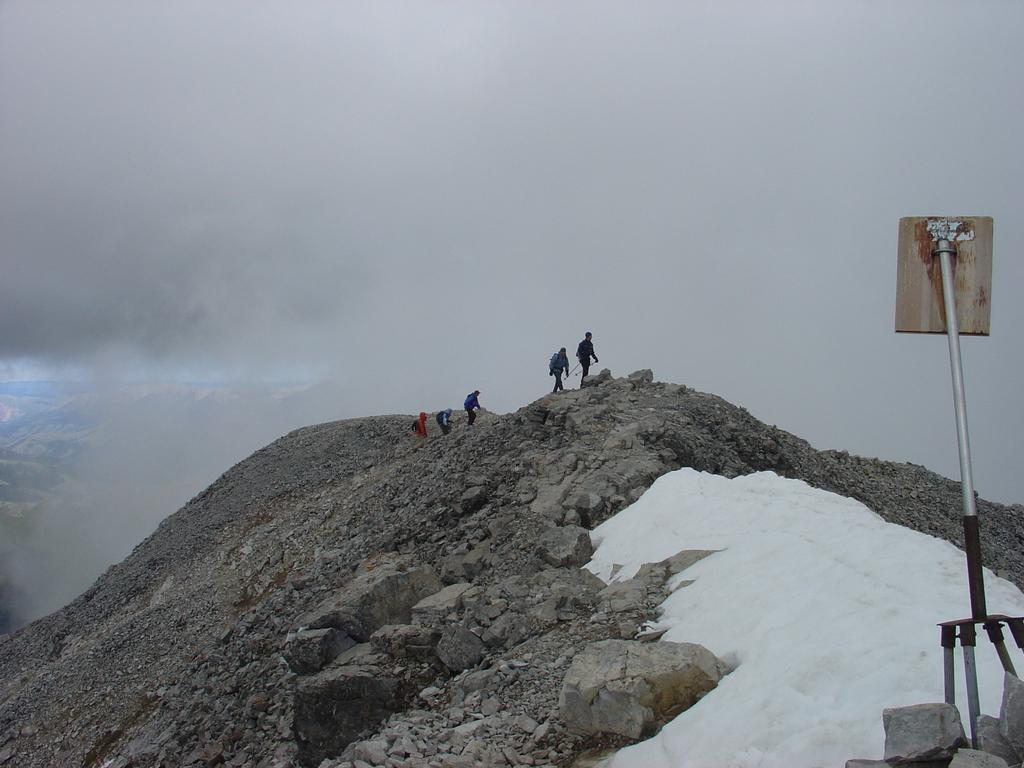What type of natural elements can be seen in the image? There are rocks and snow visible in the image. Are there any human subjects in the image? Yes, there are people in the image. What structures can be seen in the image? There is a pole and a board in the image. What is visible in the background of the image? Sky is visible in the background of the image, with clouds present. Can you see a bird perched on the pole in the image? There is no bird present on the pole or anywhere else in the image. What type of fruit is hanging from the board in the image? There is no fruit, including bananas, depicted on the board or anywhere else in the image. 